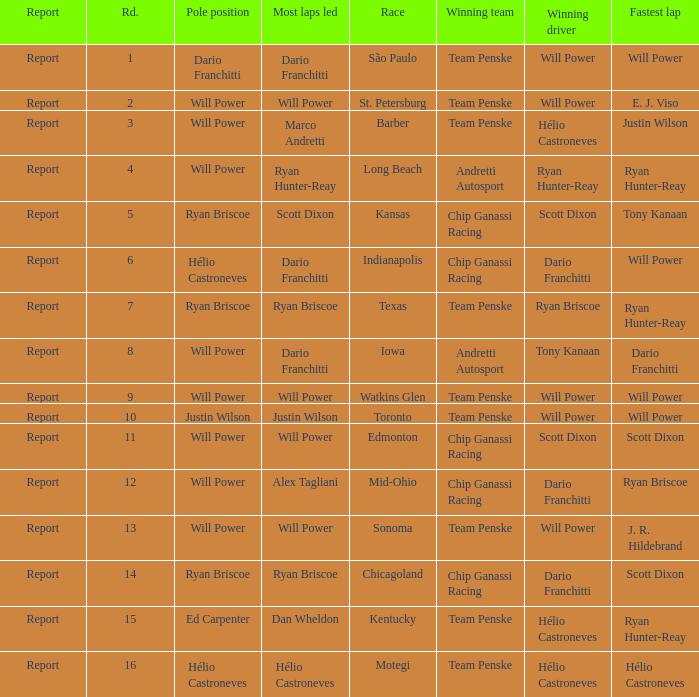What is the report for races where Will Power had both pole position and fastest lap? Report. 